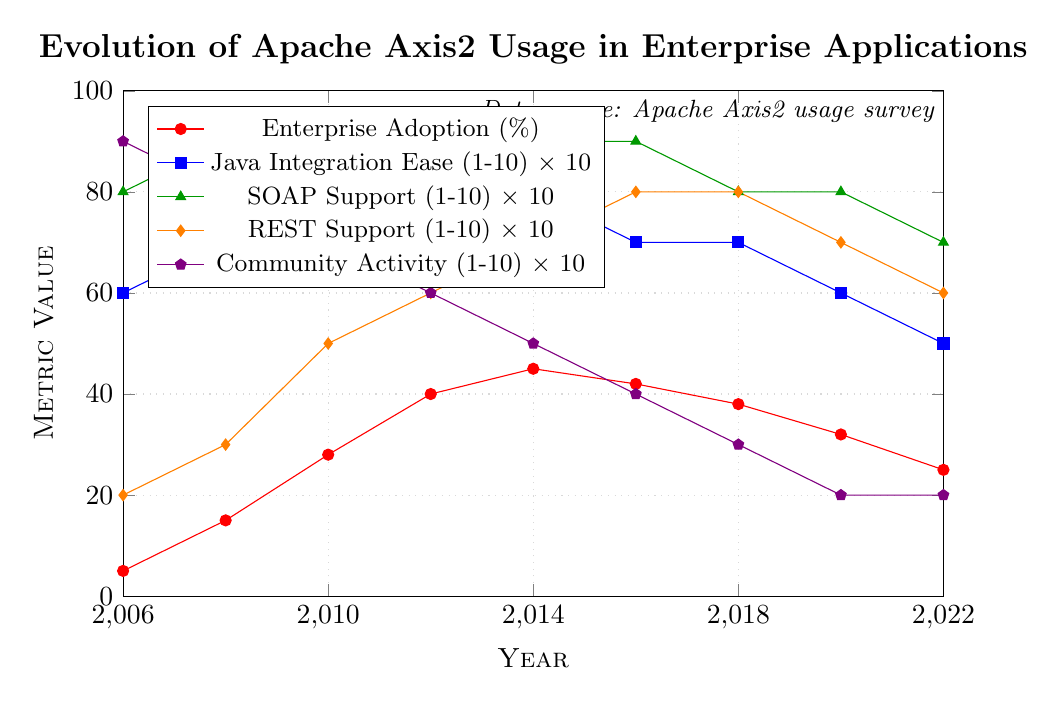What was the peak year for Enterprise Adoption percentage of Apache Axis2? By looking at the red line representing "Enterprise Adoption (%)", we can observe that the peak occurs at 2014 with a value of 45%.
Answer: 2014 How much did Java Integration Ease score change from 2006 to 2022? By referring to the blue line for "Java Integration Ease (1-10) x 10", the score in 2006 was 60, and it decreased to 50 in 2022. The change is \( 60 - 50 = 10 \).
Answer: 10 Compare the values of SOAP Support in 2010 and REST Support in 2018. Which one is higher? The values for SOAP Support and REST Support are indicated by the green and orange lines respectively. In 2010, SOAP Support is at 90, while in 2018, REST Support is at 80. SOAP Support in 2010 is higher than REST Support in 2018.
Answer: SOAP Support in 2010 What is the difference between the highest and lowest Community Activity scores? The violet line for "Community Activity (1-10) x 10" shows that the highest score was 90 in 2006, and the lowest score was 20 from 2020 onwards. The difference is \( 90 - 20 = 70 \).
Answer: 70 Between which consecutive years did Enterprise Adoption percentage decrease for the first time? The red line showing "Enterprise Adoption (%)" indicates a decrease between 2014 and 2016. The value went from 45% in 2014 to 42% in 2016, marking the first decrease.
Answer: 2014 to 2016 In what year did REST Support reach its maximum score and what was the value? The orange line representing "REST Support (1-10) x 10" shows that the maximum score is 80, reached in both 2016 and 2018.
Answer: 2016 and 2018; 80 What's the average value of Enterprise Adoption percentage from 2006 to 2022? The Enterprise Adoption percentages are 5, 15, 28, 40, 45, 42, 38, 32, and 25. Summing these values: \( 5 + 15 + 28 + 40 + 45 + 42 + 38 + 32 + 25 = 270 \). There are 9 data points, so the average is \( 270/9 = 30 \).
Answer: 30 Did Community Activity ever increase between two adjacent years? If yes, between which years? Following the violet line for "Community Activity (1-10) x 10", the score consistently decreases over the years without any increase between adjacent years.
Answer: No 